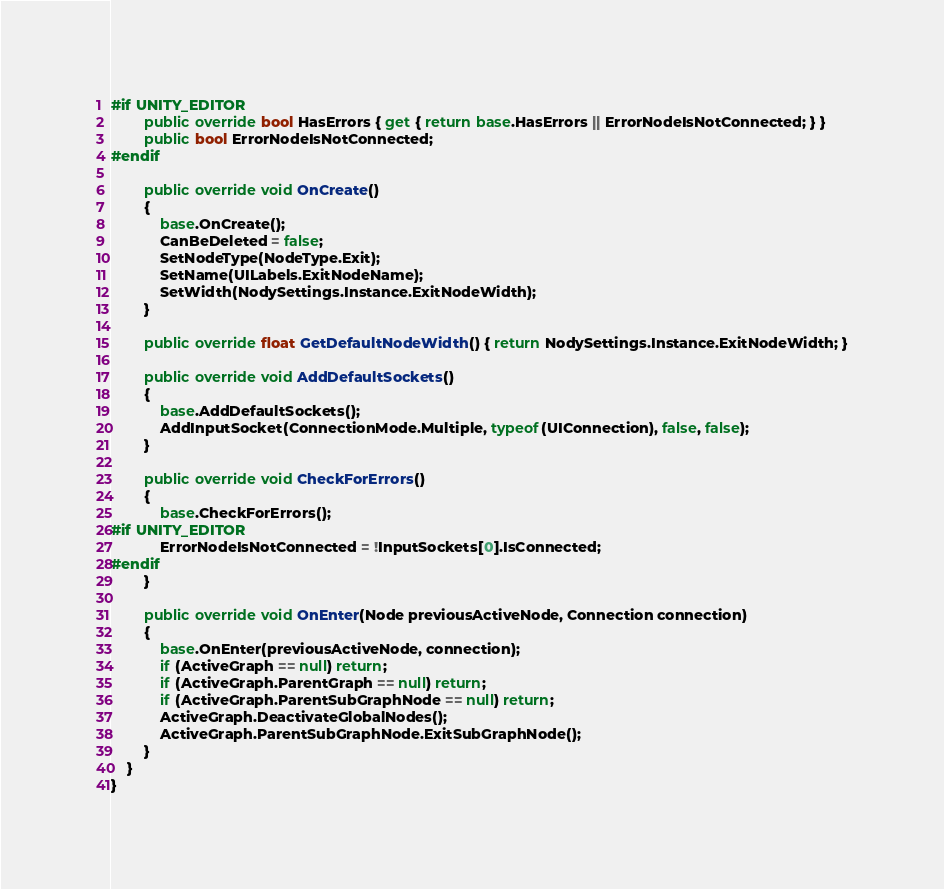<code> <loc_0><loc_0><loc_500><loc_500><_C#_>#if UNITY_EDITOR
        public override bool HasErrors { get { return base.HasErrors || ErrorNodeIsNotConnected; } }
        public bool ErrorNodeIsNotConnected;
#endif
        
        public override void OnCreate()
        {
            base.OnCreate();
            CanBeDeleted = false;
            SetNodeType(NodeType.Exit);
            SetName(UILabels.ExitNodeName);
            SetWidth(NodySettings.Instance.ExitNodeWidth);
        }

        public override float GetDefaultNodeWidth() { return NodySettings.Instance.ExitNodeWidth; }
        
        public override void AddDefaultSockets()
        {
            base.AddDefaultSockets();
            AddInputSocket(ConnectionMode.Multiple, typeof(UIConnection), false, false);
        }

        public override void CheckForErrors()
        {
            base.CheckForErrors();
#if UNITY_EDITOR
            ErrorNodeIsNotConnected = !InputSockets[0].IsConnected;
#endif
        }

        public override void OnEnter(Node previousActiveNode, Connection connection)
        {
            base.OnEnter(previousActiveNode, connection);
            if (ActiveGraph == null) return;
            if (ActiveGraph.ParentGraph == null) return;
            if (ActiveGraph.ParentSubGraphNode == null) return;
            ActiveGraph.DeactivateGlobalNodes();
            ActiveGraph.ParentSubGraphNode.ExitSubGraphNode();
        }
    }
}</code> 